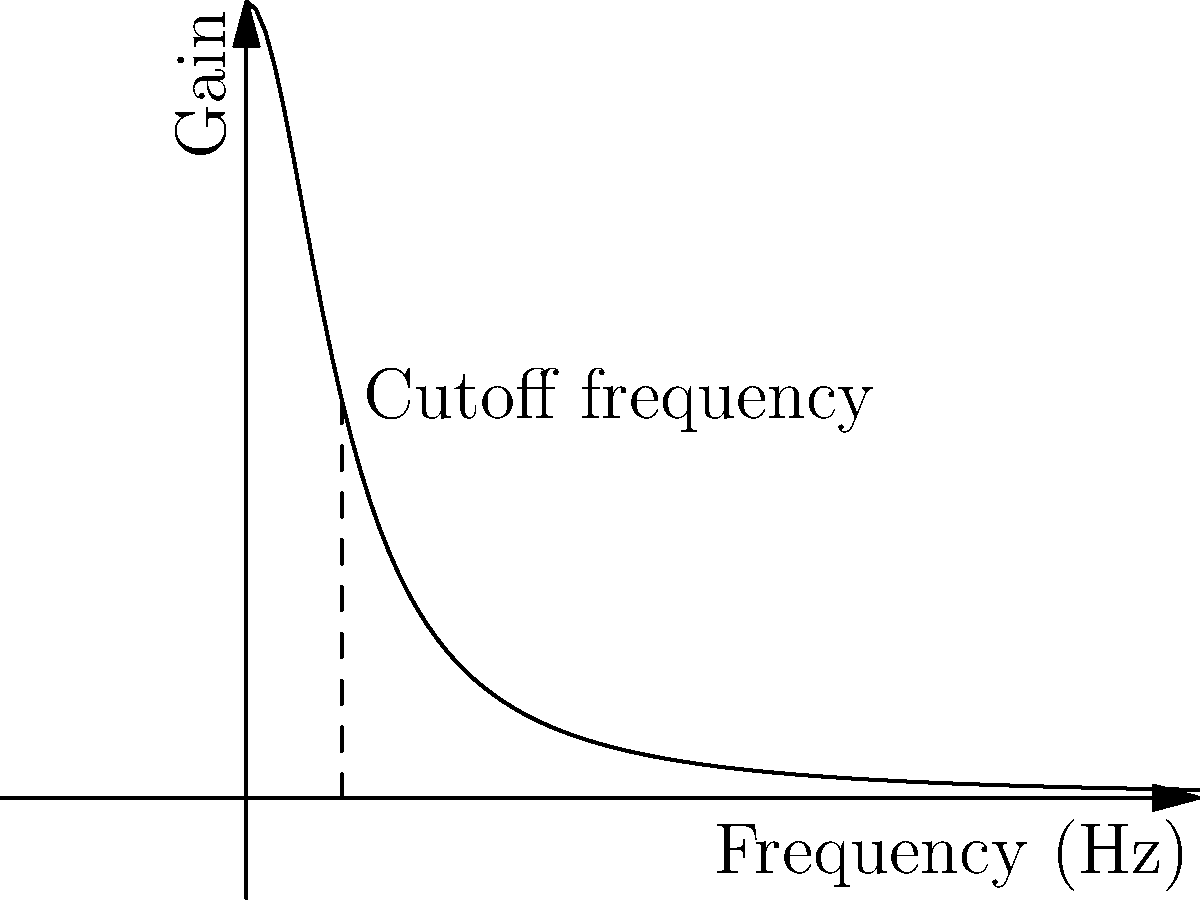In a urinary flow measurement system, a sensor with the frequency response shown above is used. If the cutoff frequency is 1 Hz, what is the gain of the sensor at a frequency of 2 Hz? To solve this problem, we need to follow these steps:

1. Identify the transfer function: The graph represents a low-pass filter with a transfer function of the form $H(f) = \frac{1}{1+(f/f_c)^2}$, where $f$ is the frequency and $f_c$ is the cutoff frequency.

2. Note the cutoff frequency: The question states that the cutoff frequency $f_c = 1$ Hz.

3. Calculate the gain at 2 Hz: We need to find $H(2)$ given $f_c = 1$ Hz.

4. Substitute the values into the transfer function:
   $H(2) = \frac{1}{1+(2/1)^2} = \frac{1}{1+4} = \frac{1}{5}$

5. Simplify: $H(2) = 0.2$

Therefore, at a frequency of 2 Hz, the gain of the sensor is 0.2 or 20% of the DC gain.
Answer: 0.2 